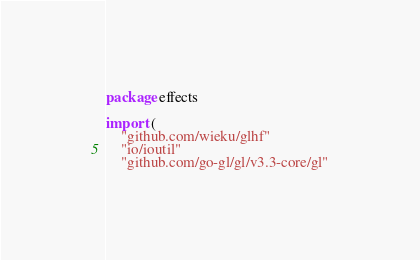Convert code to text. <code><loc_0><loc_0><loc_500><loc_500><_Go_>package effects

import (
	"github.com/wieku/glhf"
	"io/ioutil"
	"github.com/go-gl/gl/v3.3-core/gl"</code> 